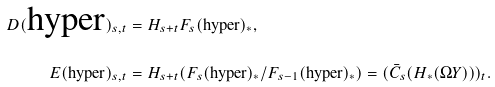Convert formula to latex. <formula><loc_0><loc_0><loc_500><loc_500>D ( \text {hyper} ) _ { s , t } & = H _ { s + t } F _ { s } ( \text {hyper} ) _ { * } , \\ E ( \text {hyper} ) _ { s , t } & = H _ { s + t } ( F _ { s } ( \text {hyper} ) _ { * } / F _ { s - 1 } ( \text {hyper} ) _ { * } ) = ( \bar { C } _ { s } ( H _ { * } ( \Omega Y ) ) ) _ { t } .</formula> 